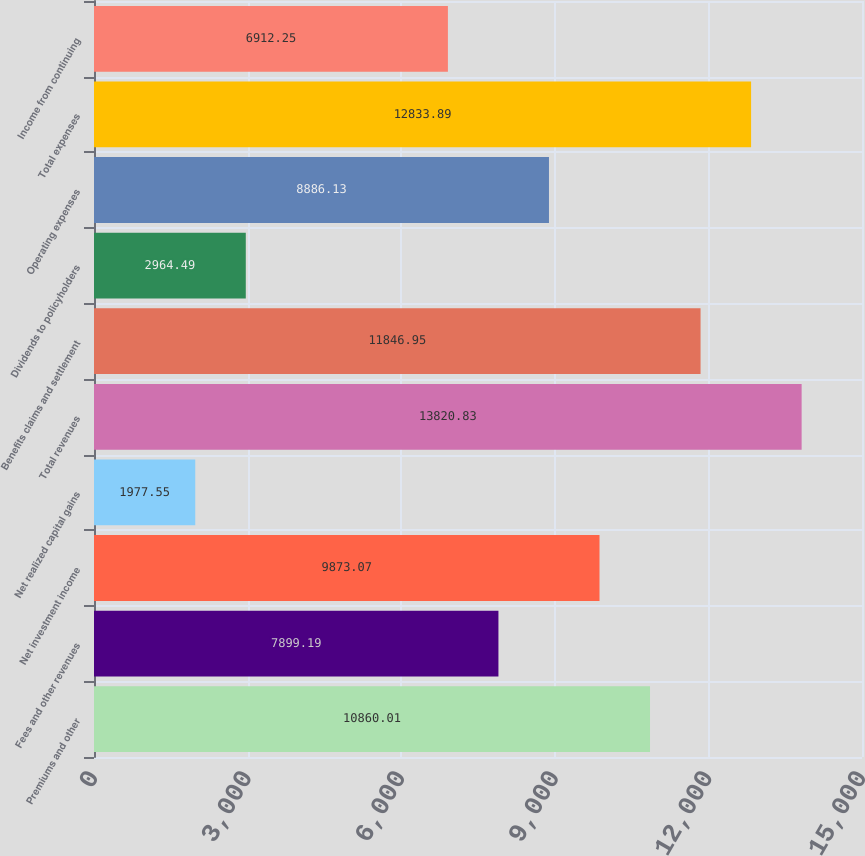Convert chart to OTSL. <chart><loc_0><loc_0><loc_500><loc_500><bar_chart><fcel>Premiums and other<fcel>Fees and other revenues<fcel>Net investment income<fcel>Net realized capital gains<fcel>Total revenues<fcel>Benefits claims and settlement<fcel>Dividends to policyholders<fcel>Operating expenses<fcel>Total expenses<fcel>Income from continuing<nl><fcel>10860<fcel>7899.19<fcel>9873.07<fcel>1977.55<fcel>13820.8<fcel>11847<fcel>2964.49<fcel>8886.13<fcel>12833.9<fcel>6912.25<nl></chart> 